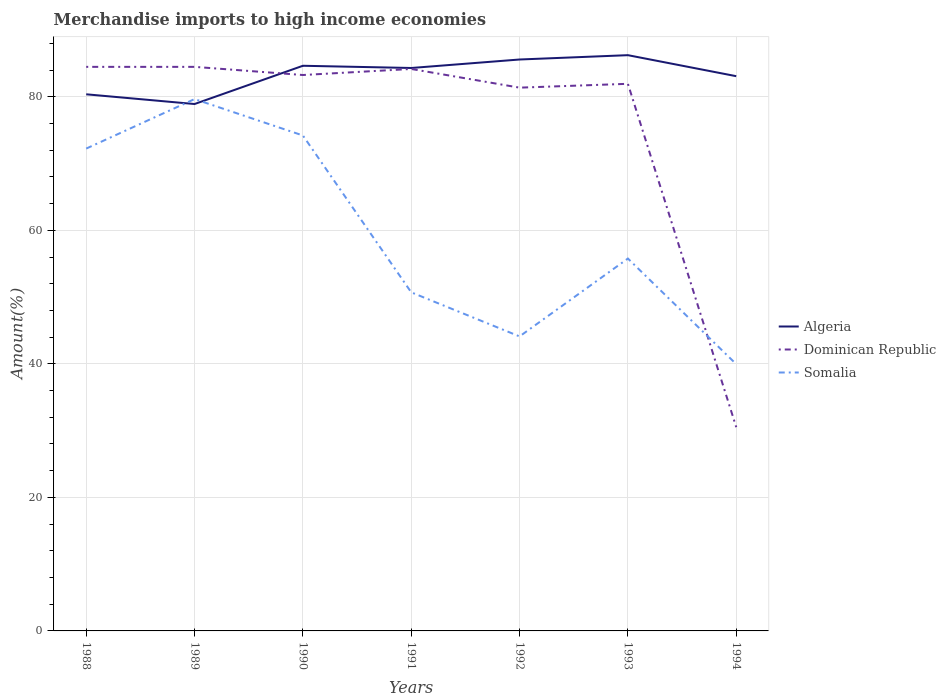Is the number of lines equal to the number of legend labels?
Give a very brief answer. Yes. Across all years, what is the maximum percentage of amount earned from merchandise imports in Algeria?
Provide a short and direct response. 78.91. In which year was the percentage of amount earned from merchandise imports in Algeria maximum?
Ensure brevity in your answer.  1989. What is the total percentage of amount earned from merchandise imports in Dominican Republic in the graph?
Give a very brief answer. 1.22. What is the difference between the highest and the second highest percentage of amount earned from merchandise imports in Somalia?
Give a very brief answer. 39.7. What is the difference between the highest and the lowest percentage of amount earned from merchandise imports in Algeria?
Give a very brief answer. 4. Is the percentage of amount earned from merchandise imports in Somalia strictly greater than the percentage of amount earned from merchandise imports in Algeria over the years?
Your answer should be very brief. No. How many lines are there?
Keep it short and to the point. 3. Are the values on the major ticks of Y-axis written in scientific E-notation?
Offer a terse response. No. Does the graph contain any zero values?
Your response must be concise. No. Does the graph contain grids?
Your answer should be very brief. Yes. How are the legend labels stacked?
Ensure brevity in your answer.  Vertical. What is the title of the graph?
Make the answer very short. Merchandise imports to high income economies. What is the label or title of the X-axis?
Your answer should be compact. Years. What is the label or title of the Y-axis?
Your answer should be very brief. Amount(%). What is the Amount(%) in Algeria in 1988?
Provide a succinct answer. 80.37. What is the Amount(%) in Dominican Republic in 1988?
Offer a terse response. 84.48. What is the Amount(%) in Somalia in 1988?
Ensure brevity in your answer.  72.24. What is the Amount(%) in Algeria in 1989?
Your answer should be very brief. 78.91. What is the Amount(%) in Dominican Republic in 1989?
Provide a succinct answer. 84.48. What is the Amount(%) of Somalia in 1989?
Your answer should be very brief. 79.65. What is the Amount(%) of Algeria in 1990?
Your response must be concise. 84.64. What is the Amount(%) in Dominican Republic in 1990?
Give a very brief answer. 83.26. What is the Amount(%) of Somalia in 1990?
Provide a short and direct response. 74.2. What is the Amount(%) of Algeria in 1991?
Offer a terse response. 84.31. What is the Amount(%) of Dominican Republic in 1991?
Give a very brief answer. 84.16. What is the Amount(%) of Somalia in 1991?
Your response must be concise. 50.71. What is the Amount(%) in Algeria in 1992?
Keep it short and to the point. 85.58. What is the Amount(%) in Dominican Republic in 1992?
Your answer should be compact. 81.36. What is the Amount(%) in Somalia in 1992?
Your answer should be very brief. 44.11. What is the Amount(%) of Algeria in 1993?
Keep it short and to the point. 86.23. What is the Amount(%) in Dominican Republic in 1993?
Make the answer very short. 81.94. What is the Amount(%) of Somalia in 1993?
Provide a short and direct response. 55.77. What is the Amount(%) in Algeria in 1994?
Your answer should be very brief. 83.08. What is the Amount(%) in Dominican Republic in 1994?
Offer a terse response. 30.51. What is the Amount(%) in Somalia in 1994?
Ensure brevity in your answer.  39.95. Across all years, what is the maximum Amount(%) of Algeria?
Keep it short and to the point. 86.23. Across all years, what is the maximum Amount(%) in Dominican Republic?
Offer a very short reply. 84.48. Across all years, what is the maximum Amount(%) of Somalia?
Keep it short and to the point. 79.65. Across all years, what is the minimum Amount(%) of Algeria?
Your answer should be very brief. 78.91. Across all years, what is the minimum Amount(%) of Dominican Republic?
Give a very brief answer. 30.51. Across all years, what is the minimum Amount(%) of Somalia?
Make the answer very short. 39.95. What is the total Amount(%) of Algeria in the graph?
Keep it short and to the point. 583.12. What is the total Amount(%) in Dominican Republic in the graph?
Your response must be concise. 530.2. What is the total Amount(%) of Somalia in the graph?
Offer a very short reply. 416.63. What is the difference between the Amount(%) of Algeria in 1988 and that in 1989?
Make the answer very short. 1.46. What is the difference between the Amount(%) of Dominican Republic in 1988 and that in 1989?
Provide a succinct answer. -0. What is the difference between the Amount(%) in Somalia in 1988 and that in 1989?
Your response must be concise. -7.41. What is the difference between the Amount(%) in Algeria in 1988 and that in 1990?
Your answer should be very brief. -4.27. What is the difference between the Amount(%) of Dominican Republic in 1988 and that in 1990?
Offer a terse response. 1.22. What is the difference between the Amount(%) in Somalia in 1988 and that in 1990?
Your response must be concise. -1.96. What is the difference between the Amount(%) in Algeria in 1988 and that in 1991?
Offer a very short reply. -3.94. What is the difference between the Amount(%) in Dominican Republic in 1988 and that in 1991?
Make the answer very short. 0.32. What is the difference between the Amount(%) in Somalia in 1988 and that in 1991?
Your response must be concise. 21.53. What is the difference between the Amount(%) in Algeria in 1988 and that in 1992?
Your answer should be compact. -5.21. What is the difference between the Amount(%) of Dominican Republic in 1988 and that in 1992?
Make the answer very short. 3.12. What is the difference between the Amount(%) in Somalia in 1988 and that in 1992?
Offer a terse response. 28.13. What is the difference between the Amount(%) of Algeria in 1988 and that in 1993?
Offer a terse response. -5.86. What is the difference between the Amount(%) of Dominican Republic in 1988 and that in 1993?
Offer a very short reply. 2.54. What is the difference between the Amount(%) of Somalia in 1988 and that in 1993?
Give a very brief answer. 16.47. What is the difference between the Amount(%) of Algeria in 1988 and that in 1994?
Make the answer very short. -2.71. What is the difference between the Amount(%) in Dominican Republic in 1988 and that in 1994?
Ensure brevity in your answer.  53.97. What is the difference between the Amount(%) in Somalia in 1988 and that in 1994?
Keep it short and to the point. 32.29. What is the difference between the Amount(%) of Algeria in 1989 and that in 1990?
Keep it short and to the point. -5.73. What is the difference between the Amount(%) of Dominican Republic in 1989 and that in 1990?
Give a very brief answer. 1.22. What is the difference between the Amount(%) in Somalia in 1989 and that in 1990?
Offer a terse response. 5.45. What is the difference between the Amount(%) of Algeria in 1989 and that in 1991?
Offer a terse response. -5.4. What is the difference between the Amount(%) in Dominican Republic in 1989 and that in 1991?
Offer a terse response. 0.32. What is the difference between the Amount(%) of Somalia in 1989 and that in 1991?
Make the answer very short. 28.94. What is the difference between the Amount(%) in Algeria in 1989 and that in 1992?
Your answer should be compact. -6.67. What is the difference between the Amount(%) of Dominican Republic in 1989 and that in 1992?
Your response must be concise. 3.12. What is the difference between the Amount(%) in Somalia in 1989 and that in 1992?
Provide a succinct answer. 35.54. What is the difference between the Amount(%) in Algeria in 1989 and that in 1993?
Give a very brief answer. -7.32. What is the difference between the Amount(%) in Dominican Republic in 1989 and that in 1993?
Offer a very short reply. 2.54. What is the difference between the Amount(%) of Somalia in 1989 and that in 1993?
Give a very brief answer. 23.88. What is the difference between the Amount(%) in Algeria in 1989 and that in 1994?
Offer a very short reply. -4.17. What is the difference between the Amount(%) in Dominican Republic in 1989 and that in 1994?
Keep it short and to the point. 53.97. What is the difference between the Amount(%) of Somalia in 1989 and that in 1994?
Keep it short and to the point. 39.7. What is the difference between the Amount(%) in Algeria in 1990 and that in 1991?
Your answer should be compact. 0.33. What is the difference between the Amount(%) in Dominican Republic in 1990 and that in 1991?
Your answer should be very brief. -0.91. What is the difference between the Amount(%) of Somalia in 1990 and that in 1991?
Give a very brief answer. 23.49. What is the difference between the Amount(%) in Algeria in 1990 and that in 1992?
Keep it short and to the point. -0.94. What is the difference between the Amount(%) in Dominican Republic in 1990 and that in 1992?
Give a very brief answer. 1.89. What is the difference between the Amount(%) in Somalia in 1990 and that in 1992?
Your response must be concise. 30.09. What is the difference between the Amount(%) of Algeria in 1990 and that in 1993?
Provide a succinct answer. -1.59. What is the difference between the Amount(%) in Dominican Republic in 1990 and that in 1993?
Provide a succinct answer. 1.32. What is the difference between the Amount(%) in Somalia in 1990 and that in 1993?
Keep it short and to the point. 18.43. What is the difference between the Amount(%) in Algeria in 1990 and that in 1994?
Your response must be concise. 1.56. What is the difference between the Amount(%) of Dominican Republic in 1990 and that in 1994?
Give a very brief answer. 52.74. What is the difference between the Amount(%) in Somalia in 1990 and that in 1994?
Give a very brief answer. 34.25. What is the difference between the Amount(%) of Algeria in 1991 and that in 1992?
Ensure brevity in your answer.  -1.27. What is the difference between the Amount(%) of Dominican Republic in 1991 and that in 1992?
Offer a terse response. 2.8. What is the difference between the Amount(%) in Somalia in 1991 and that in 1992?
Ensure brevity in your answer.  6.6. What is the difference between the Amount(%) of Algeria in 1991 and that in 1993?
Provide a succinct answer. -1.92. What is the difference between the Amount(%) in Dominican Republic in 1991 and that in 1993?
Your answer should be compact. 2.22. What is the difference between the Amount(%) of Somalia in 1991 and that in 1993?
Ensure brevity in your answer.  -5.06. What is the difference between the Amount(%) of Algeria in 1991 and that in 1994?
Ensure brevity in your answer.  1.23. What is the difference between the Amount(%) in Dominican Republic in 1991 and that in 1994?
Give a very brief answer. 53.65. What is the difference between the Amount(%) of Somalia in 1991 and that in 1994?
Offer a terse response. 10.76. What is the difference between the Amount(%) in Algeria in 1992 and that in 1993?
Keep it short and to the point. -0.65. What is the difference between the Amount(%) in Dominican Republic in 1992 and that in 1993?
Your response must be concise. -0.58. What is the difference between the Amount(%) of Somalia in 1992 and that in 1993?
Offer a terse response. -11.66. What is the difference between the Amount(%) of Algeria in 1992 and that in 1994?
Ensure brevity in your answer.  2.5. What is the difference between the Amount(%) in Dominican Republic in 1992 and that in 1994?
Your answer should be compact. 50.85. What is the difference between the Amount(%) of Somalia in 1992 and that in 1994?
Your answer should be compact. 4.15. What is the difference between the Amount(%) of Algeria in 1993 and that in 1994?
Provide a short and direct response. 3.15. What is the difference between the Amount(%) in Dominican Republic in 1993 and that in 1994?
Offer a very short reply. 51.43. What is the difference between the Amount(%) of Somalia in 1993 and that in 1994?
Keep it short and to the point. 15.82. What is the difference between the Amount(%) in Algeria in 1988 and the Amount(%) in Dominican Republic in 1989?
Give a very brief answer. -4.11. What is the difference between the Amount(%) of Algeria in 1988 and the Amount(%) of Somalia in 1989?
Your answer should be very brief. 0.72. What is the difference between the Amount(%) of Dominican Republic in 1988 and the Amount(%) of Somalia in 1989?
Your answer should be very brief. 4.83. What is the difference between the Amount(%) in Algeria in 1988 and the Amount(%) in Dominican Republic in 1990?
Your answer should be compact. -2.89. What is the difference between the Amount(%) in Algeria in 1988 and the Amount(%) in Somalia in 1990?
Ensure brevity in your answer.  6.17. What is the difference between the Amount(%) of Dominican Republic in 1988 and the Amount(%) of Somalia in 1990?
Provide a short and direct response. 10.28. What is the difference between the Amount(%) of Algeria in 1988 and the Amount(%) of Dominican Republic in 1991?
Offer a very short reply. -3.79. What is the difference between the Amount(%) of Algeria in 1988 and the Amount(%) of Somalia in 1991?
Your answer should be very brief. 29.66. What is the difference between the Amount(%) in Dominican Republic in 1988 and the Amount(%) in Somalia in 1991?
Give a very brief answer. 33.77. What is the difference between the Amount(%) in Algeria in 1988 and the Amount(%) in Dominican Republic in 1992?
Provide a short and direct response. -1. What is the difference between the Amount(%) of Algeria in 1988 and the Amount(%) of Somalia in 1992?
Offer a terse response. 36.26. What is the difference between the Amount(%) in Dominican Republic in 1988 and the Amount(%) in Somalia in 1992?
Offer a very short reply. 40.37. What is the difference between the Amount(%) in Algeria in 1988 and the Amount(%) in Dominican Republic in 1993?
Provide a short and direct response. -1.57. What is the difference between the Amount(%) of Algeria in 1988 and the Amount(%) of Somalia in 1993?
Your answer should be very brief. 24.6. What is the difference between the Amount(%) in Dominican Republic in 1988 and the Amount(%) in Somalia in 1993?
Your response must be concise. 28.71. What is the difference between the Amount(%) in Algeria in 1988 and the Amount(%) in Dominican Republic in 1994?
Provide a succinct answer. 49.86. What is the difference between the Amount(%) of Algeria in 1988 and the Amount(%) of Somalia in 1994?
Make the answer very short. 40.42. What is the difference between the Amount(%) in Dominican Republic in 1988 and the Amount(%) in Somalia in 1994?
Your response must be concise. 44.53. What is the difference between the Amount(%) in Algeria in 1989 and the Amount(%) in Dominican Republic in 1990?
Offer a very short reply. -4.35. What is the difference between the Amount(%) of Algeria in 1989 and the Amount(%) of Somalia in 1990?
Your answer should be compact. 4.71. What is the difference between the Amount(%) of Dominican Republic in 1989 and the Amount(%) of Somalia in 1990?
Offer a very short reply. 10.28. What is the difference between the Amount(%) of Algeria in 1989 and the Amount(%) of Dominican Republic in 1991?
Provide a succinct answer. -5.25. What is the difference between the Amount(%) of Algeria in 1989 and the Amount(%) of Somalia in 1991?
Provide a short and direct response. 28.2. What is the difference between the Amount(%) in Dominican Republic in 1989 and the Amount(%) in Somalia in 1991?
Keep it short and to the point. 33.77. What is the difference between the Amount(%) in Algeria in 1989 and the Amount(%) in Dominican Republic in 1992?
Your answer should be very brief. -2.45. What is the difference between the Amount(%) of Algeria in 1989 and the Amount(%) of Somalia in 1992?
Offer a terse response. 34.81. What is the difference between the Amount(%) of Dominican Republic in 1989 and the Amount(%) of Somalia in 1992?
Make the answer very short. 40.37. What is the difference between the Amount(%) of Algeria in 1989 and the Amount(%) of Dominican Republic in 1993?
Your answer should be compact. -3.03. What is the difference between the Amount(%) of Algeria in 1989 and the Amount(%) of Somalia in 1993?
Give a very brief answer. 23.14. What is the difference between the Amount(%) of Dominican Republic in 1989 and the Amount(%) of Somalia in 1993?
Your response must be concise. 28.71. What is the difference between the Amount(%) of Algeria in 1989 and the Amount(%) of Dominican Republic in 1994?
Provide a succinct answer. 48.4. What is the difference between the Amount(%) in Algeria in 1989 and the Amount(%) in Somalia in 1994?
Your answer should be very brief. 38.96. What is the difference between the Amount(%) in Dominican Republic in 1989 and the Amount(%) in Somalia in 1994?
Offer a very short reply. 44.53. What is the difference between the Amount(%) of Algeria in 1990 and the Amount(%) of Dominican Republic in 1991?
Offer a terse response. 0.48. What is the difference between the Amount(%) of Algeria in 1990 and the Amount(%) of Somalia in 1991?
Offer a terse response. 33.93. What is the difference between the Amount(%) of Dominican Republic in 1990 and the Amount(%) of Somalia in 1991?
Offer a terse response. 32.55. What is the difference between the Amount(%) in Algeria in 1990 and the Amount(%) in Dominican Republic in 1992?
Provide a succinct answer. 3.28. What is the difference between the Amount(%) of Algeria in 1990 and the Amount(%) of Somalia in 1992?
Give a very brief answer. 40.53. What is the difference between the Amount(%) in Dominican Republic in 1990 and the Amount(%) in Somalia in 1992?
Provide a succinct answer. 39.15. What is the difference between the Amount(%) of Algeria in 1990 and the Amount(%) of Dominican Republic in 1993?
Your answer should be compact. 2.7. What is the difference between the Amount(%) in Algeria in 1990 and the Amount(%) in Somalia in 1993?
Provide a succinct answer. 28.87. What is the difference between the Amount(%) of Dominican Republic in 1990 and the Amount(%) of Somalia in 1993?
Your answer should be compact. 27.49. What is the difference between the Amount(%) in Algeria in 1990 and the Amount(%) in Dominican Republic in 1994?
Your answer should be compact. 54.13. What is the difference between the Amount(%) of Algeria in 1990 and the Amount(%) of Somalia in 1994?
Your answer should be compact. 44.69. What is the difference between the Amount(%) in Dominican Republic in 1990 and the Amount(%) in Somalia in 1994?
Make the answer very short. 43.31. What is the difference between the Amount(%) of Algeria in 1991 and the Amount(%) of Dominican Republic in 1992?
Give a very brief answer. 2.94. What is the difference between the Amount(%) in Algeria in 1991 and the Amount(%) in Somalia in 1992?
Offer a terse response. 40.2. What is the difference between the Amount(%) in Dominican Republic in 1991 and the Amount(%) in Somalia in 1992?
Your response must be concise. 40.06. What is the difference between the Amount(%) in Algeria in 1991 and the Amount(%) in Dominican Republic in 1993?
Keep it short and to the point. 2.37. What is the difference between the Amount(%) in Algeria in 1991 and the Amount(%) in Somalia in 1993?
Keep it short and to the point. 28.54. What is the difference between the Amount(%) in Dominican Republic in 1991 and the Amount(%) in Somalia in 1993?
Provide a succinct answer. 28.39. What is the difference between the Amount(%) in Algeria in 1991 and the Amount(%) in Dominican Republic in 1994?
Ensure brevity in your answer.  53.8. What is the difference between the Amount(%) of Algeria in 1991 and the Amount(%) of Somalia in 1994?
Ensure brevity in your answer.  44.36. What is the difference between the Amount(%) of Dominican Republic in 1991 and the Amount(%) of Somalia in 1994?
Provide a succinct answer. 44.21. What is the difference between the Amount(%) of Algeria in 1992 and the Amount(%) of Dominican Republic in 1993?
Offer a terse response. 3.64. What is the difference between the Amount(%) of Algeria in 1992 and the Amount(%) of Somalia in 1993?
Give a very brief answer. 29.81. What is the difference between the Amount(%) in Dominican Republic in 1992 and the Amount(%) in Somalia in 1993?
Provide a succinct answer. 25.59. What is the difference between the Amount(%) of Algeria in 1992 and the Amount(%) of Dominican Republic in 1994?
Your answer should be very brief. 55.07. What is the difference between the Amount(%) of Algeria in 1992 and the Amount(%) of Somalia in 1994?
Give a very brief answer. 45.63. What is the difference between the Amount(%) in Dominican Republic in 1992 and the Amount(%) in Somalia in 1994?
Ensure brevity in your answer.  41.41. What is the difference between the Amount(%) in Algeria in 1993 and the Amount(%) in Dominican Republic in 1994?
Your answer should be very brief. 55.72. What is the difference between the Amount(%) in Algeria in 1993 and the Amount(%) in Somalia in 1994?
Your response must be concise. 46.28. What is the difference between the Amount(%) in Dominican Republic in 1993 and the Amount(%) in Somalia in 1994?
Your answer should be compact. 41.99. What is the average Amount(%) in Algeria per year?
Make the answer very short. 83.3. What is the average Amount(%) in Dominican Republic per year?
Provide a succinct answer. 75.74. What is the average Amount(%) in Somalia per year?
Make the answer very short. 59.52. In the year 1988, what is the difference between the Amount(%) of Algeria and Amount(%) of Dominican Republic?
Provide a short and direct response. -4.11. In the year 1988, what is the difference between the Amount(%) in Algeria and Amount(%) in Somalia?
Keep it short and to the point. 8.13. In the year 1988, what is the difference between the Amount(%) in Dominican Republic and Amount(%) in Somalia?
Provide a short and direct response. 12.24. In the year 1989, what is the difference between the Amount(%) of Algeria and Amount(%) of Dominican Republic?
Provide a short and direct response. -5.57. In the year 1989, what is the difference between the Amount(%) of Algeria and Amount(%) of Somalia?
Your answer should be compact. -0.74. In the year 1989, what is the difference between the Amount(%) of Dominican Republic and Amount(%) of Somalia?
Offer a terse response. 4.83. In the year 1990, what is the difference between the Amount(%) in Algeria and Amount(%) in Dominican Republic?
Your answer should be compact. 1.38. In the year 1990, what is the difference between the Amount(%) in Algeria and Amount(%) in Somalia?
Provide a succinct answer. 10.44. In the year 1990, what is the difference between the Amount(%) in Dominican Republic and Amount(%) in Somalia?
Keep it short and to the point. 9.06. In the year 1991, what is the difference between the Amount(%) of Algeria and Amount(%) of Dominican Republic?
Ensure brevity in your answer.  0.15. In the year 1991, what is the difference between the Amount(%) in Algeria and Amount(%) in Somalia?
Ensure brevity in your answer.  33.6. In the year 1991, what is the difference between the Amount(%) of Dominican Republic and Amount(%) of Somalia?
Ensure brevity in your answer.  33.45. In the year 1992, what is the difference between the Amount(%) in Algeria and Amount(%) in Dominican Republic?
Your response must be concise. 4.22. In the year 1992, what is the difference between the Amount(%) in Algeria and Amount(%) in Somalia?
Make the answer very short. 41.47. In the year 1992, what is the difference between the Amount(%) in Dominican Republic and Amount(%) in Somalia?
Give a very brief answer. 37.26. In the year 1993, what is the difference between the Amount(%) of Algeria and Amount(%) of Dominican Republic?
Your answer should be compact. 4.29. In the year 1993, what is the difference between the Amount(%) of Algeria and Amount(%) of Somalia?
Offer a very short reply. 30.46. In the year 1993, what is the difference between the Amount(%) of Dominican Republic and Amount(%) of Somalia?
Offer a very short reply. 26.17. In the year 1994, what is the difference between the Amount(%) in Algeria and Amount(%) in Dominican Republic?
Make the answer very short. 52.57. In the year 1994, what is the difference between the Amount(%) in Algeria and Amount(%) in Somalia?
Give a very brief answer. 43.13. In the year 1994, what is the difference between the Amount(%) in Dominican Republic and Amount(%) in Somalia?
Your response must be concise. -9.44. What is the ratio of the Amount(%) in Algeria in 1988 to that in 1989?
Give a very brief answer. 1.02. What is the ratio of the Amount(%) of Somalia in 1988 to that in 1989?
Provide a short and direct response. 0.91. What is the ratio of the Amount(%) of Algeria in 1988 to that in 1990?
Give a very brief answer. 0.95. What is the ratio of the Amount(%) of Dominican Republic in 1988 to that in 1990?
Your response must be concise. 1.01. What is the ratio of the Amount(%) in Somalia in 1988 to that in 1990?
Offer a very short reply. 0.97. What is the ratio of the Amount(%) of Algeria in 1988 to that in 1991?
Give a very brief answer. 0.95. What is the ratio of the Amount(%) in Somalia in 1988 to that in 1991?
Ensure brevity in your answer.  1.42. What is the ratio of the Amount(%) of Algeria in 1988 to that in 1992?
Provide a succinct answer. 0.94. What is the ratio of the Amount(%) of Dominican Republic in 1988 to that in 1992?
Your answer should be compact. 1.04. What is the ratio of the Amount(%) of Somalia in 1988 to that in 1992?
Provide a succinct answer. 1.64. What is the ratio of the Amount(%) of Algeria in 1988 to that in 1993?
Make the answer very short. 0.93. What is the ratio of the Amount(%) in Dominican Republic in 1988 to that in 1993?
Your response must be concise. 1.03. What is the ratio of the Amount(%) of Somalia in 1988 to that in 1993?
Your answer should be very brief. 1.3. What is the ratio of the Amount(%) in Algeria in 1988 to that in 1994?
Give a very brief answer. 0.97. What is the ratio of the Amount(%) of Dominican Republic in 1988 to that in 1994?
Provide a succinct answer. 2.77. What is the ratio of the Amount(%) of Somalia in 1988 to that in 1994?
Give a very brief answer. 1.81. What is the ratio of the Amount(%) in Algeria in 1989 to that in 1990?
Your response must be concise. 0.93. What is the ratio of the Amount(%) of Dominican Republic in 1989 to that in 1990?
Keep it short and to the point. 1.01. What is the ratio of the Amount(%) of Somalia in 1989 to that in 1990?
Keep it short and to the point. 1.07. What is the ratio of the Amount(%) in Algeria in 1989 to that in 1991?
Your response must be concise. 0.94. What is the ratio of the Amount(%) in Somalia in 1989 to that in 1991?
Keep it short and to the point. 1.57. What is the ratio of the Amount(%) of Algeria in 1989 to that in 1992?
Your response must be concise. 0.92. What is the ratio of the Amount(%) in Dominican Republic in 1989 to that in 1992?
Offer a very short reply. 1.04. What is the ratio of the Amount(%) in Somalia in 1989 to that in 1992?
Keep it short and to the point. 1.81. What is the ratio of the Amount(%) of Algeria in 1989 to that in 1993?
Offer a very short reply. 0.92. What is the ratio of the Amount(%) of Dominican Republic in 1989 to that in 1993?
Keep it short and to the point. 1.03. What is the ratio of the Amount(%) in Somalia in 1989 to that in 1993?
Your response must be concise. 1.43. What is the ratio of the Amount(%) in Algeria in 1989 to that in 1994?
Offer a very short reply. 0.95. What is the ratio of the Amount(%) of Dominican Republic in 1989 to that in 1994?
Your answer should be very brief. 2.77. What is the ratio of the Amount(%) in Somalia in 1989 to that in 1994?
Provide a short and direct response. 1.99. What is the ratio of the Amount(%) of Somalia in 1990 to that in 1991?
Your response must be concise. 1.46. What is the ratio of the Amount(%) of Algeria in 1990 to that in 1992?
Your answer should be compact. 0.99. What is the ratio of the Amount(%) in Dominican Republic in 1990 to that in 1992?
Give a very brief answer. 1.02. What is the ratio of the Amount(%) in Somalia in 1990 to that in 1992?
Provide a succinct answer. 1.68. What is the ratio of the Amount(%) in Algeria in 1990 to that in 1993?
Your answer should be compact. 0.98. What is the ratio of the Amount(%) in Dominican Republic in 1990 to that in 1993?
Keep it short and to the point. 1.02. What is the ratio of the Amount(%) of Somalia in 1990 to that in 1993?
Offer a very short reply. 1.33. What is the ratio of the Amount(%) in Algeria in 1990 to that in 1994?
Give a very brief answer. 1.02. What is the ratio of the Amount(%) in Dominican Republic in 1990 to that in 1994?
Make the answer very short. 2.73. What is the ratio of the Amount(%) of Somalia in 1990 to that in 1994?
Provide a short and direct response. 1.86. What is the ratio of the Amount(%) of Algeria in 1991 to that in 1992?
Make the answer very short. 0.99. What is the ratio of the Amount(%) of Dominican Republic in 1991 to that in 1992?
Provide a succinct answer. 1.03. What is the ratio of the Amount(%) of Somalia in 1991 to that in 1992?
Provide a short and direct response. 1.15. What is the ratio of the Amount(%) in Algeria in 1991 to that in 1993?
Your answer should be compact. 0.98. What is the ratio of the Amount(%) in Dominican Republic in 1991 to that in 1993?
Make the answer very short. 1.03. What is the ratio of the Amount(%) of Somalia in 1991 to that in 1993?
Keep it short and to the point. 0.91. What is the ratio of the Amount(%) in Algeria in 1991 to that in 1994?
Your answer should be compact. 1.01. What is the ratio of the Amount(%) in Dominican Republic in 1991 to that in 1994?
Ensure brevity in your answer.  2.76. What is the ratio of the Amount(%) of Somalia in 1991 to that in 1994?
Provide a succinct answer. 1.27. What is the ratio of the Amount(%) in Algeria in 1992 to that in 1993?
Offer a terse response. 0.99. What is the ratio of the Amount(%) of Somalia in 1992 to that in 1993?
Your answer should be very brief. 0.79. What is the ratio of the Amount(%) in Algeria in 1992 to that in 1994?
Make the answer very short. 1.03. What is the ratio of the Amount(%) of Dominican Republic in 1992 to that in 1994?
Offer a terse response. 2.67. What is the ratio of the Amount(%) in Somalia in 1992 to that in 1994?
Your response must be concise. 1.1. What is the ratio of the Amount(%) of Algeria in 1993 to that in 1994?
Provide a short and direct response. 1.04. What is the ratio of the Amount(%) in Dominican Republic in 1993 to that in 1994?
Your response must be concise. 2.69. What is the ratio of the Amount(%) of Somalia in 1993 to that in 1994?
Your answer should be compact. 1.4. What is the difference between the highest and the second highest Amount(%) of Algeria?
Your answer should be very brief. 0.65. What is the difference between the highest and the second highest Amount(%) in Somalia?
Provide a short and direct response. 5.45. What is the difference between the highest and the lowest Amount(%) in Algeria?
Offer a terse response. 7.32. What is the difference between the highest and the lowest Amount(%) of Dominican Republic?
Your response must be concise. 53.97. What is the difference between the highest and the lowest Amount(%) in Somalia?
Offer a very short reply. 39.7. 